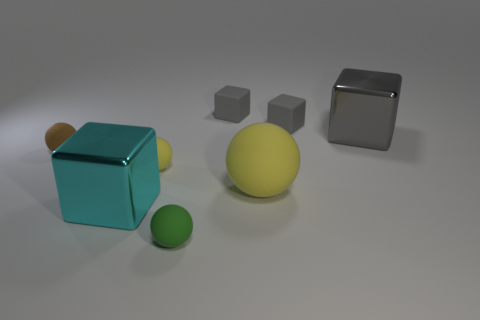How many gray cubes must be subtracted to get 1 gray cubes? 2 Subtract all large gray metal blocks. How many blocks are left? 3 Add 1 tiny yellow rubber cylinders. How many objects exist? 9 Subtract all green balls. How many balls are left? 3 Subtract 1 balls. How many balls are left? 3 Add 5 gray objects. How many gray objects exist? 8 Subtract 0 red cylinders. How many objects are left? 8 Subtract all blue blocks. Subtract all purple cylinders. How many blocks are left? 4 Subtract all gray blocks. How many yellow balls are left? 2 Subtract all small green blocks. Subtract all gray matte objects. How many objects are left? 6 